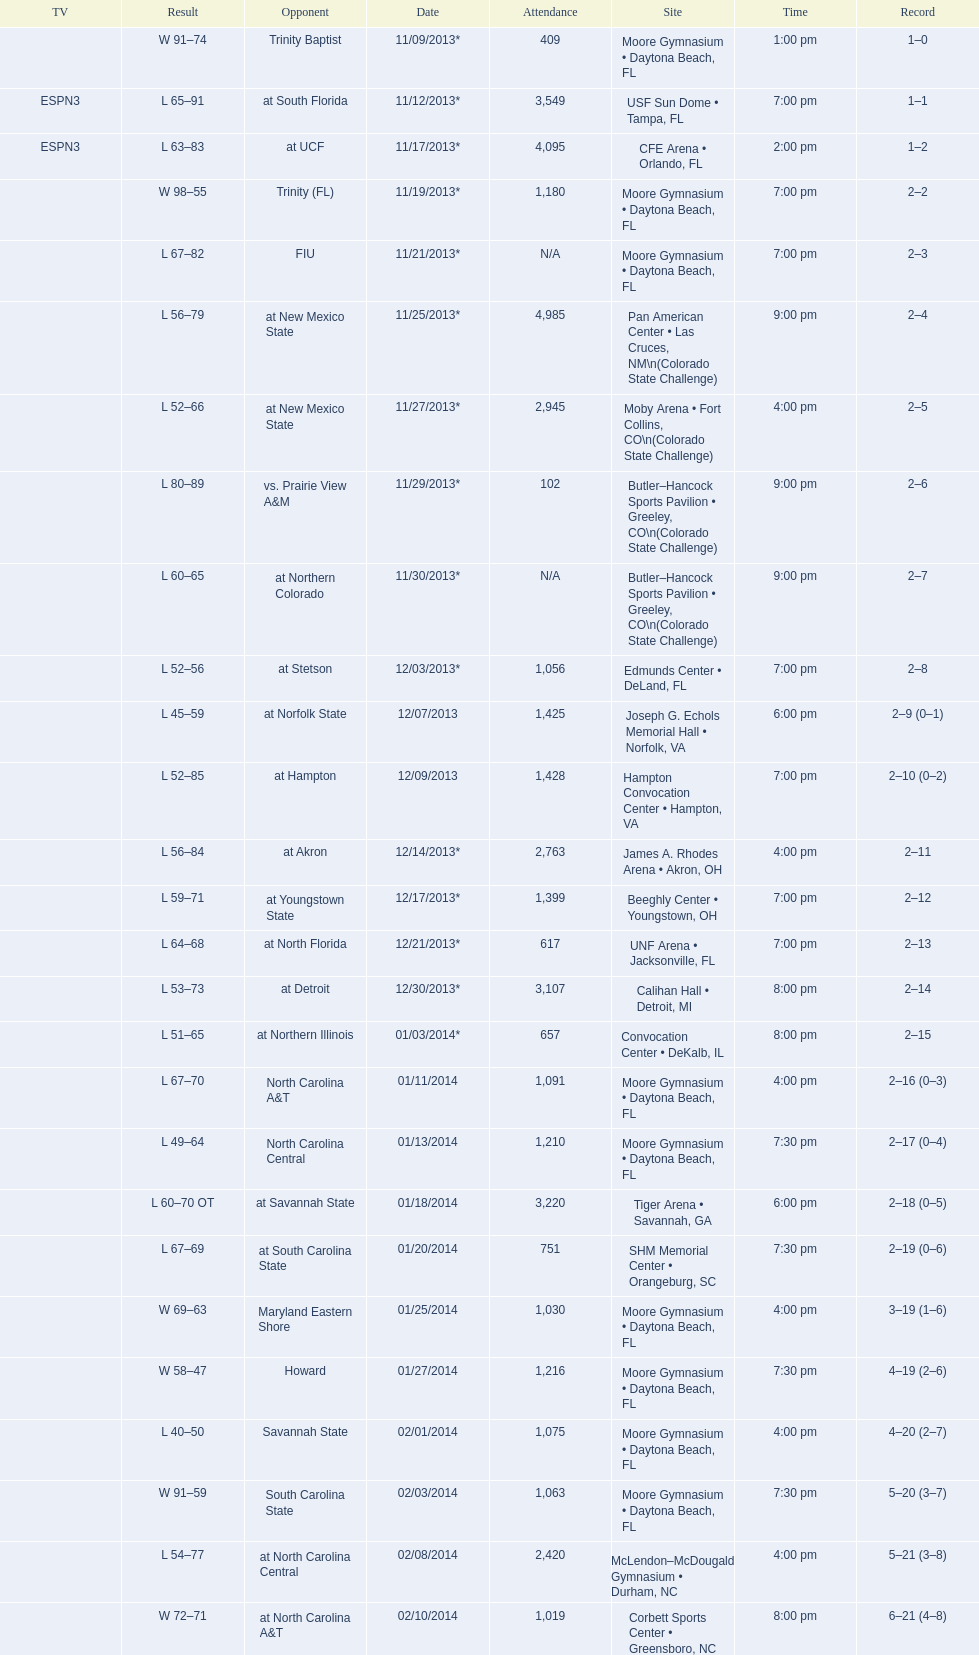In daytona beach, fl, how many games were participated in by the wildcats? 11. 